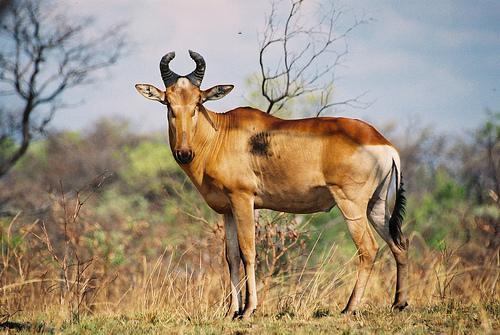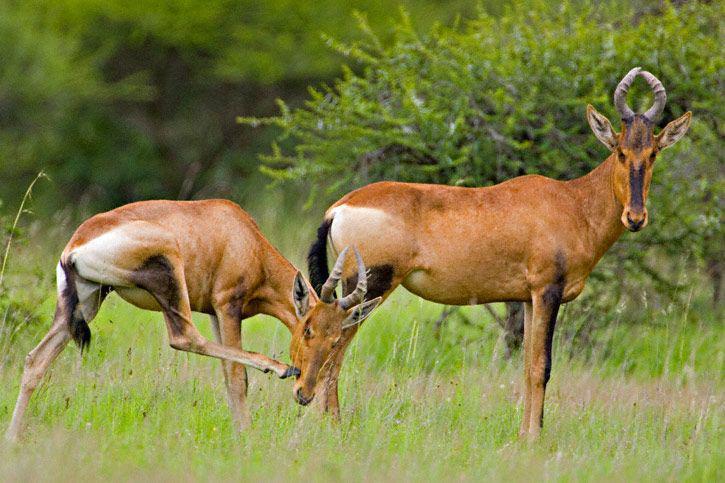The first image is the image on the left, the second image is the image on the right. Considering the images on both sides, is "The right image shows two antelope in the grass." valid? Answer yes or no. Yes. The first image is the image on the left, the second image is the image on the right. For the images shown, is this caption "The right image contains at twice as many horned animals as the left image." true? Answer yes or no. Yes. 